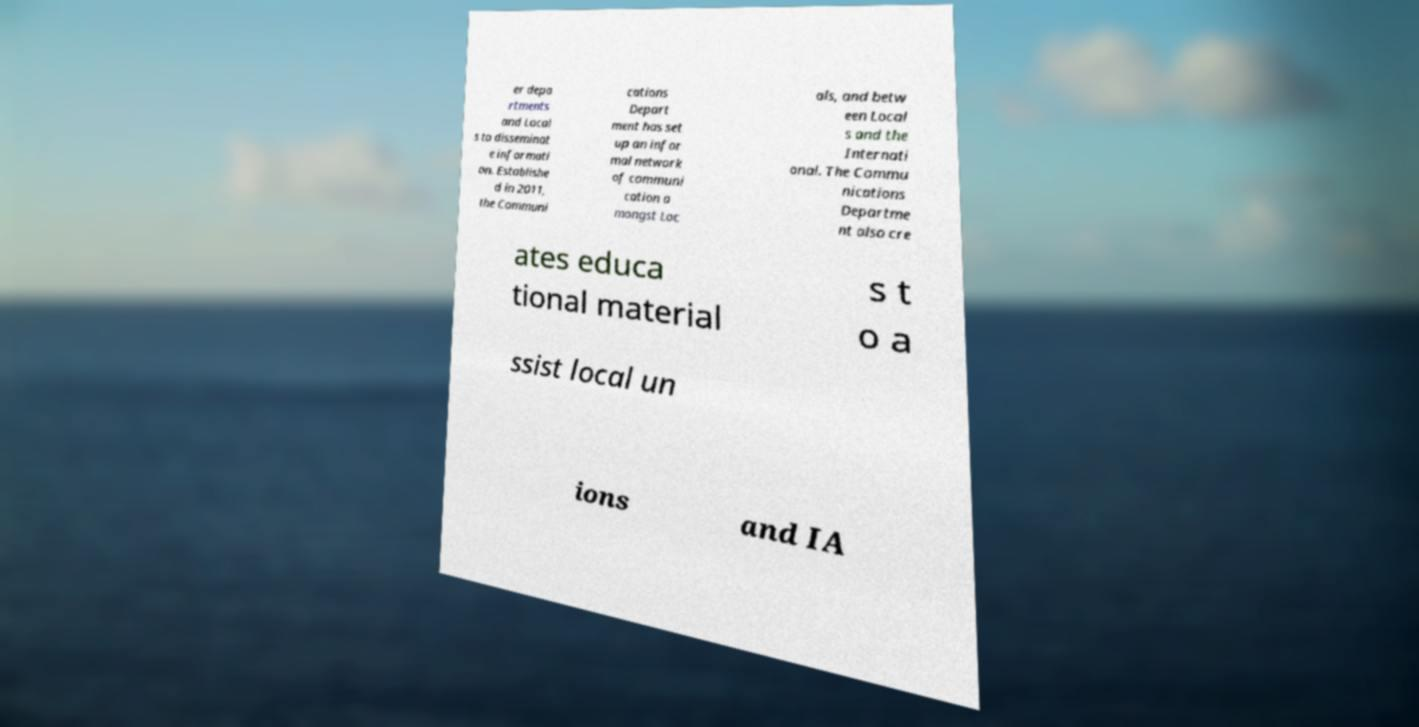Could you extract and type out the text from this image? er depa rtments and Local s to disseminat e informati on. Establishe d in 2011, the Communi cations Depart ment has set up an infor mal network of communi cation a mongst Loc als, and betw een Local s and the Internati onal. The Commu nications Departme nt also cre ates educa tional material s t o a ssist local un ions and IA 